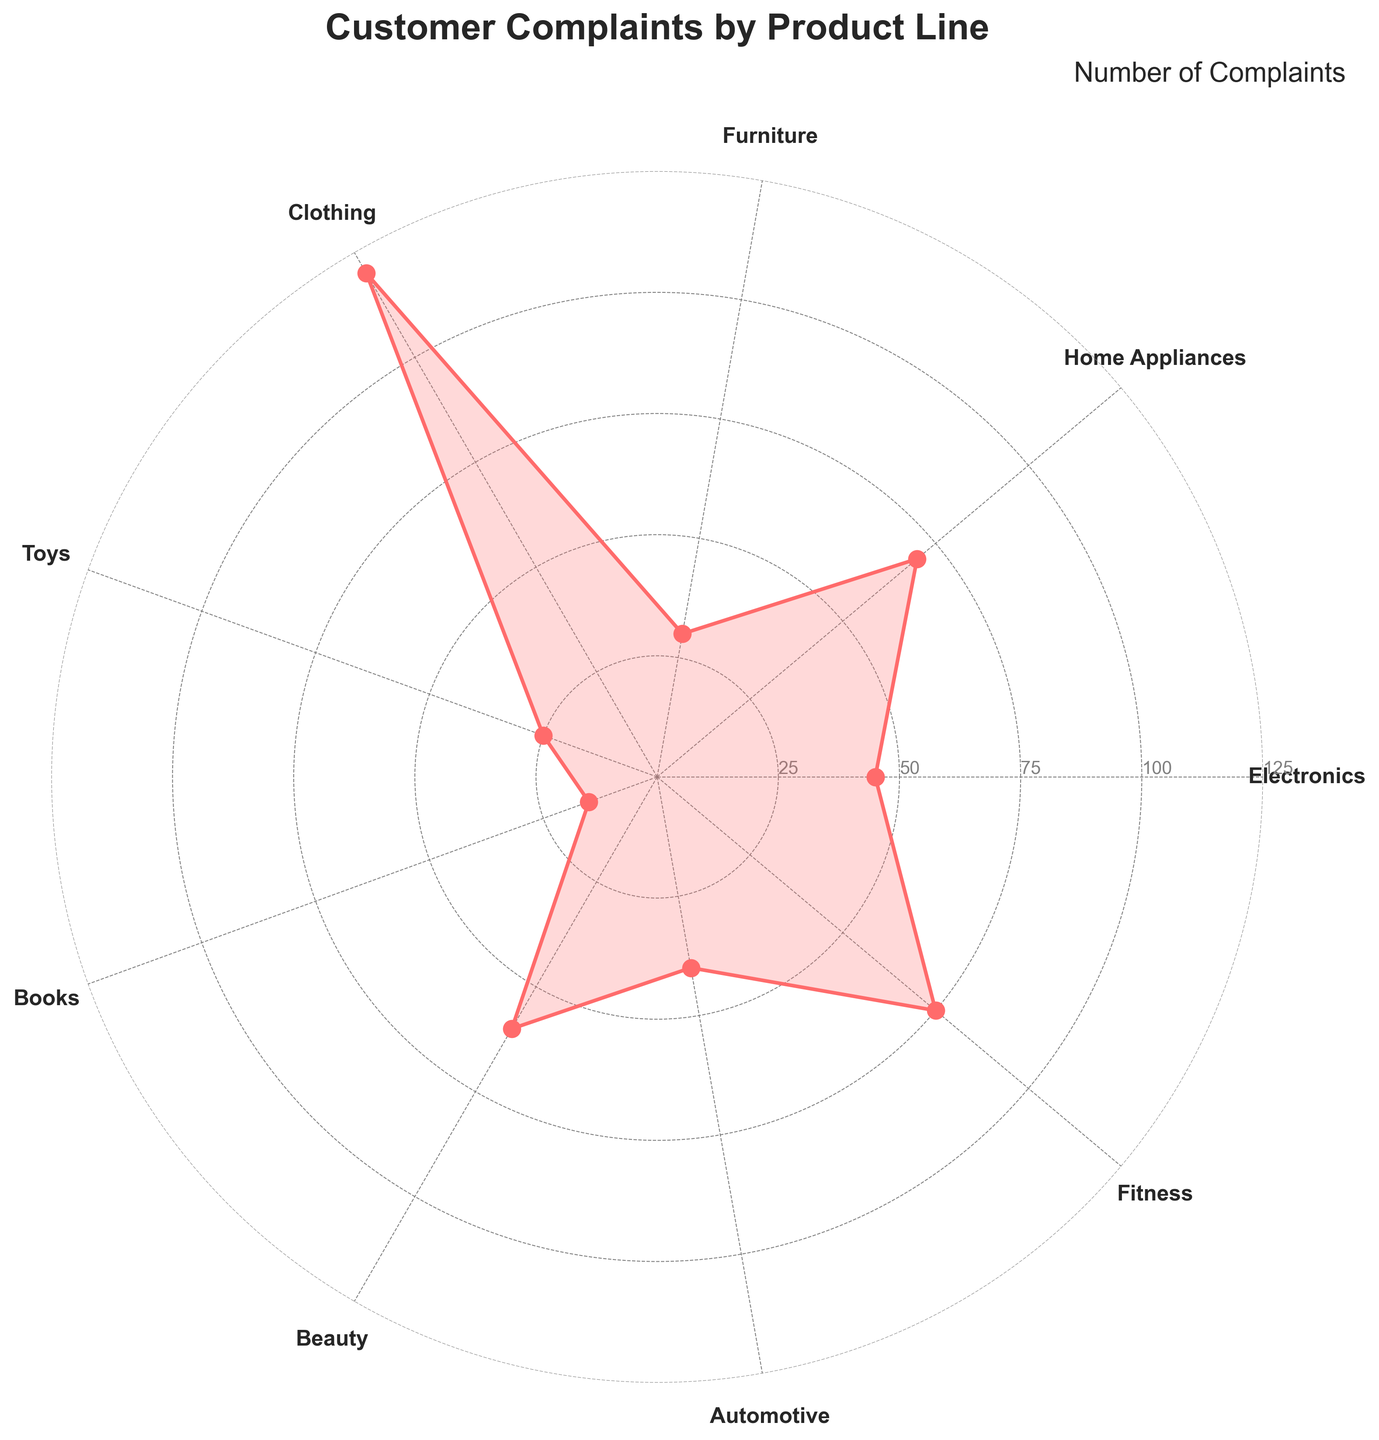What's the title of the polar chart? The title is located at the top of the chart and is prominent. The text is in a large, bold font.
Answer: Customer Complaints by Product Line Which product line has the highest number of customer complaints? By looking at the peak of the plot, you can see the highest value is for the category labeled "Clothing."
Answer: Clothing What is the range of customer complaints represented on the y-axis? The y-axis label can be observed with tick marks indicating numerical values, starting from 0 up to 125.
Answer: 0 to 125 How many product lines have fewer than 40 complaints? By looking at each data point and counting those that fall below the 40 mark on the y-axis: Electronics, Furniture, Toys, and Books.
Answer: 4 What is the difference in the number of complaints between "Fitness" and "Electronics"? Fitness has 75 complaints, and Electronics has 45 complaints. The difference is computed as 75 - 45.
Answer: 30 Which two product lines have the closest number of customer complaints, and what is the difference between them? By comparing the plotted values, "Automotive" (40) and "Electronics" (45) are the closest. The difference is 45 - 40.
Answer: Automotive and Electronics, 5 What is the average number of complaints across all product lines? Adding up all complaints: 45 + 70 + 30 + 120 + 25 + 15 + 60 + 40 + 75 = 480. There are 9 product lines, so the average is 480 / 9.
Answer: 53.33 Which product lines have more than twice the number of complaints as "Books"? Books have 15 complaints. Twice that is 30. Product lines with more than 30 complaints: Electronics, Home Appliances, Clothing, Beauty, Fitness.
Answer: Electronics, Home Appliances, Clothing, Beauty, Fitness How many product lines have complaints equal to or above the third tick mark (75)? Looking at the data points that are at or exceed the 75 mark on the y-axis: Clothing, Fitness. (Note: Fitness is exactly 75).
Answer: 2 